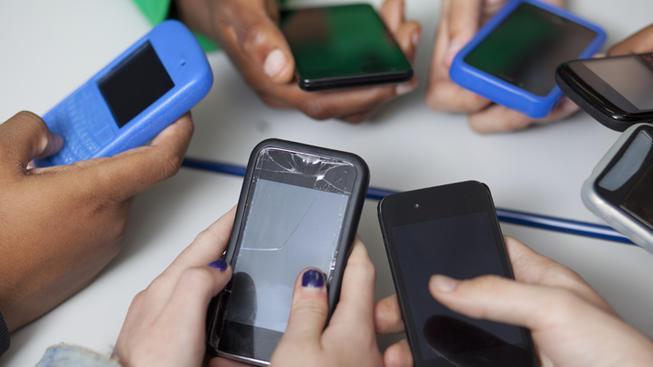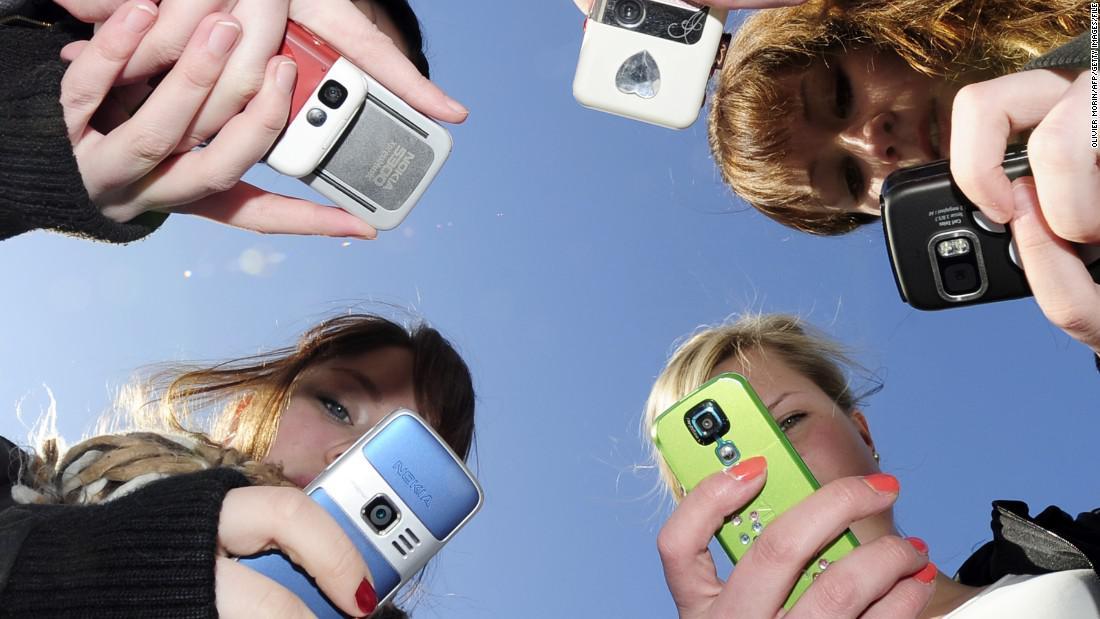The first image is the image on the left, the second image is the image on the right. Evaluate the accuracy of this statement regarding the images: "A person is using a cell phone while in a car.". Is it true? Answer yes or no. No. The first image is the image on the left, the second image is the image on the right. Analyze the images presented: Is the assertion "A person is driving and holding a cell phone in the left image." valid? Answer yes or no. No. 